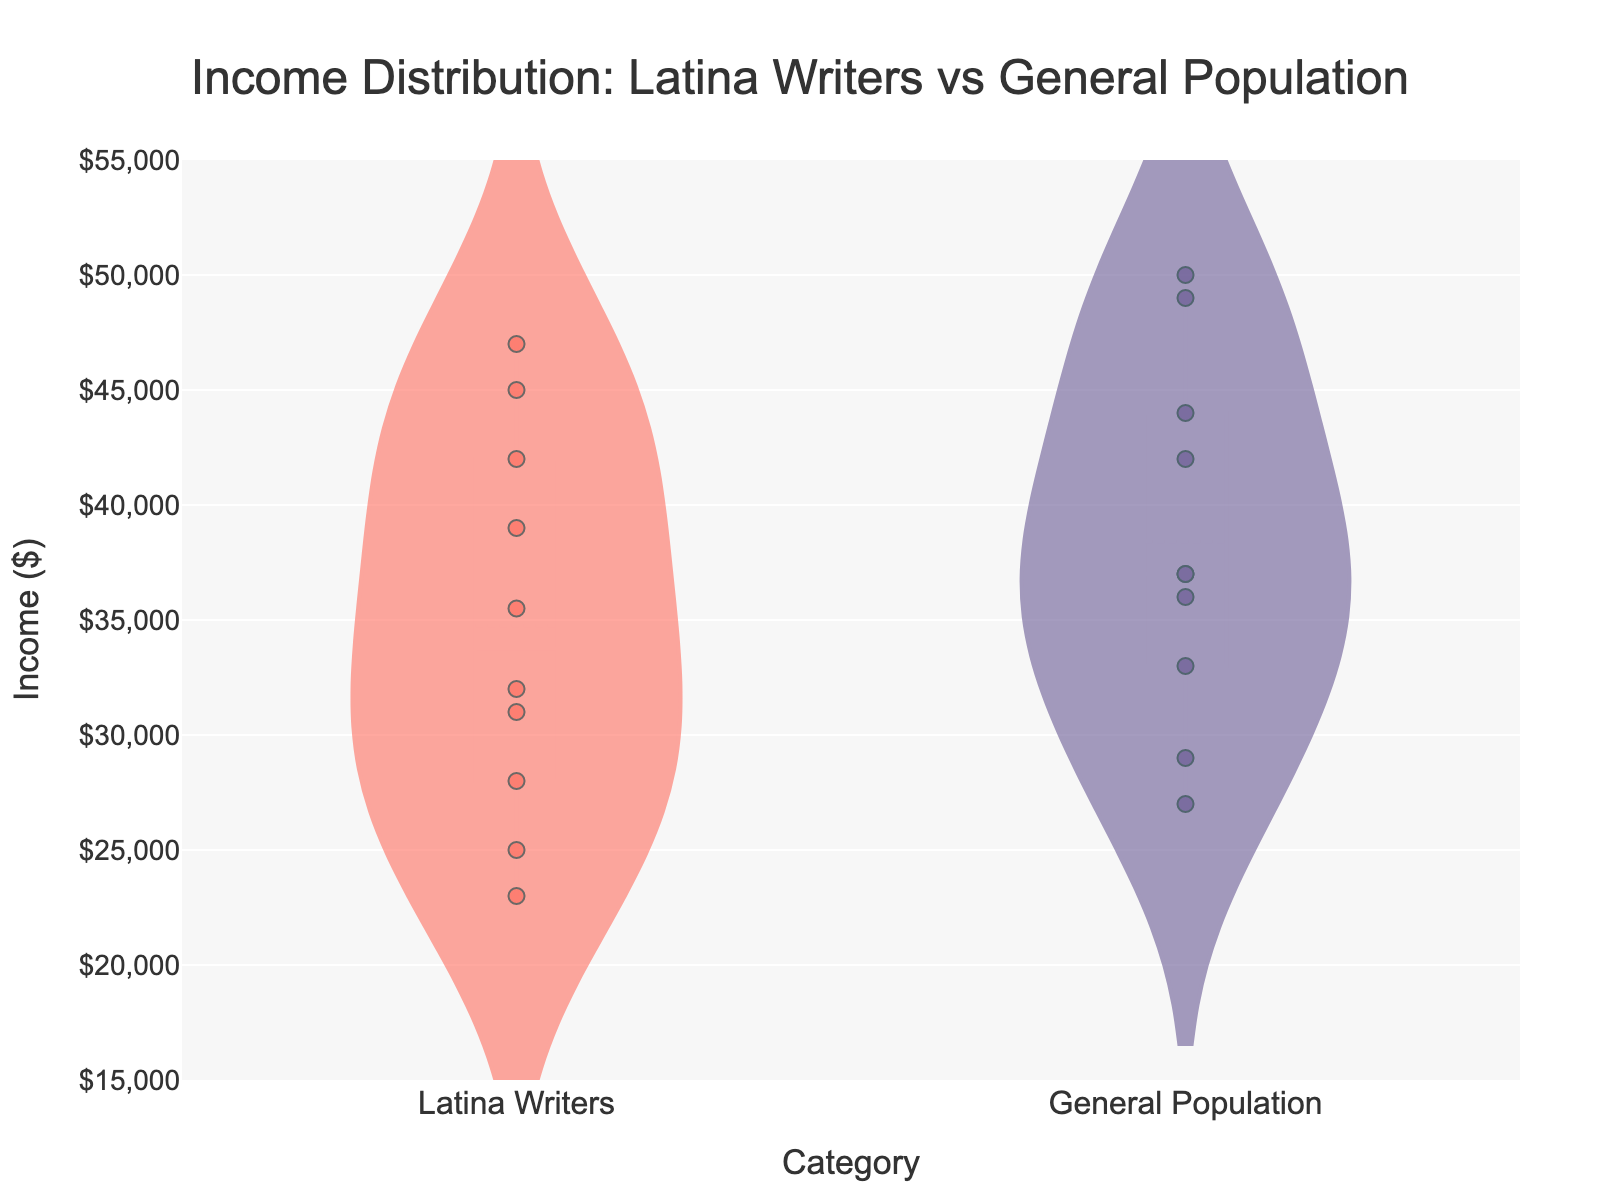How many categories are displayed in the figure? The figure shows data for two categories: "Latina Writers" and "General Population".
Answer: 2 What is the title of the figure? The title is displayed at the top of the figure and it reads "Income Distribution: Latina Writers vs General Population".
Answer: Income Distribution: Latina Writers vs General Population Which category has the highest specific data point in income? The highest data point for income is $50,000, found in the "General Population" category.
Answer: General Population What is the median income of Latina Writers? The median is represented by the thick line within the Viola. For "Latina Writers," this line is at $33,500.
Answer: $33,500 Compare the income range for "Latina Writers" and "General Population". Which category has a larger spread? The "General Population" has a larger spread of income values ranging from $27,000 to $50,000, compared to "Latina Writers" which ranges from $23,000 to $47,000.
Answer: General Population Where is the mean income line for both categories? The mean line, thinner than the median line, shows that "General Population" has a higher mean income than "Latina Writers".
Answer: General Population (higher) How does the density of income distribution compare between “Latina Writers” and “General Population”? The diestributions show that Latina Writers have more density around the median income of $33,500, while the General Population shows a broader but less dense distribution.
Answer: Latina Writers (higher density at median) What is the income value represented by the lowest data point for "Latina Writers"? The lowest data point for "Latina Writers" corresponds to $23,000.
Answer: $23,000 What is the box plot feature visible in the violin chart for both categories? The box plot feature shows the interquartile range (IQR) with a central line for the median, which is depicted within each viola for both categories.
Answer: Interquartile range and median How many data points are jittered within the "Latina Writers" category? There are 10 jittered points positioned within the "Latina Writers" category on the x-axis.
Answer: 10 